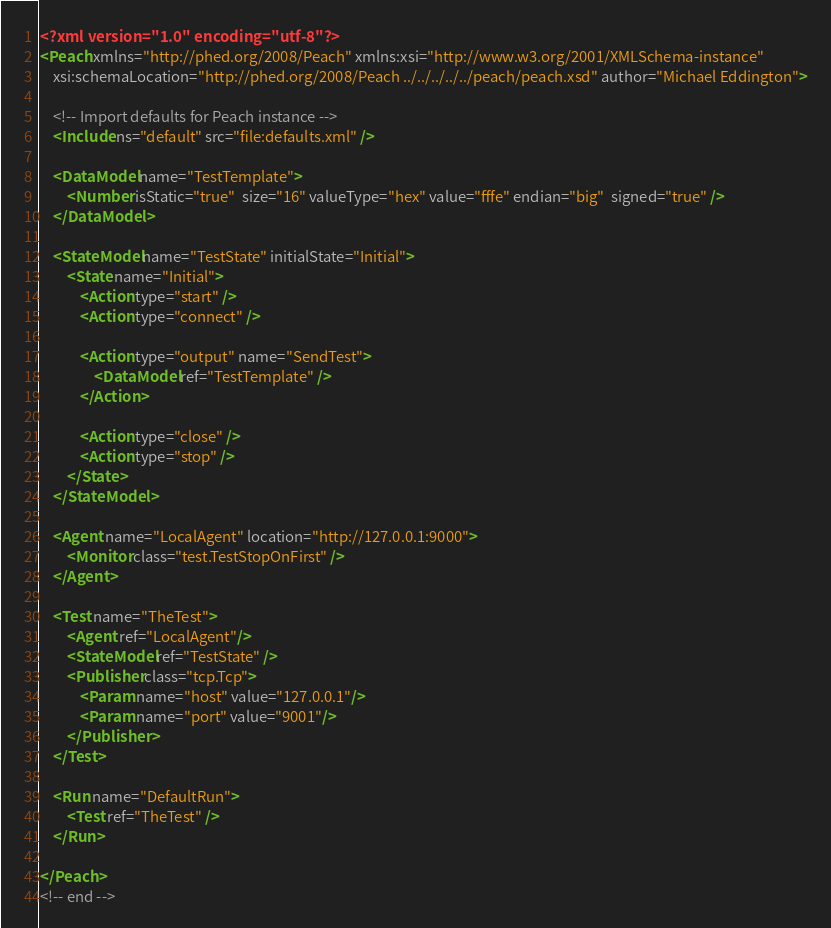Convert code to text. <code><loc_0><loc_0><loc_500><loc_500><_XML_><?xml version="1.0" encoding="utf-8"?>
<Peach xmlns="http://phed.org/2008/Peach" xmlns:xsi="http://www.w3.org/2001/XMLSchema-instance"
	xsi:schemaLocation="http://phed.org/2008/Peach ../../../../../peach/peach.xsd" author="Michael Eddington">
	
	<!-- Import defaults for Peach instance -->
	<Include ns="default" src="file:defaults.xml" />
	
	<DataModel name="TestTemplate">
		<Number isStatic="true"  size="16" valueType="hex" value="fffe" endian="big"  signed="true" />
	</DataModel>
	
	<StateModel name="TestState" initialState="Initial">
		<State name="Initial">
			<Action type="start" />
			<Action type="connect" />
			
			<Action type="output" name="SendTest">
				<DataModel ref="TestTemplate" />
			</Action>			
			
			<Action type="close" />
			<Action type="stop" />
		</State>
	</StateModel>
	
	<Agent name="LocalAgent" location="http://127.0.0.1:9000">
		<Monitor class="test.TestStopOnFirst" />
	</Agent>
	
	<Test name="TheTest">
		<Agent ref="LocalAgent"/>
		<StateModel ref="TestState" />
		<Publisher class="tcp.Tcp">
			<Param name="host" value="127.0.0.1"/>
			<Param name="port" value="9001"/>
		</Publisher>
	</Test>
	
	<Run name="DefaultRun">
		<Test ref="TheTest" />
	</Run>
	
</Peach>
<!-- end -->
</code> 